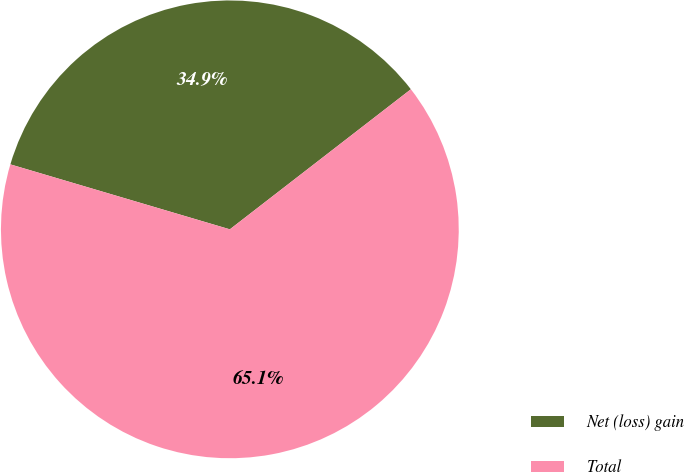Convert chart. <chart><loc_0><loc_0><loc_500><loc_500><pie_chart><fcel>Net (loss) gain<fcel>Total<nl><fcel>34.94%<fcel>65.06%<nl></chart> 